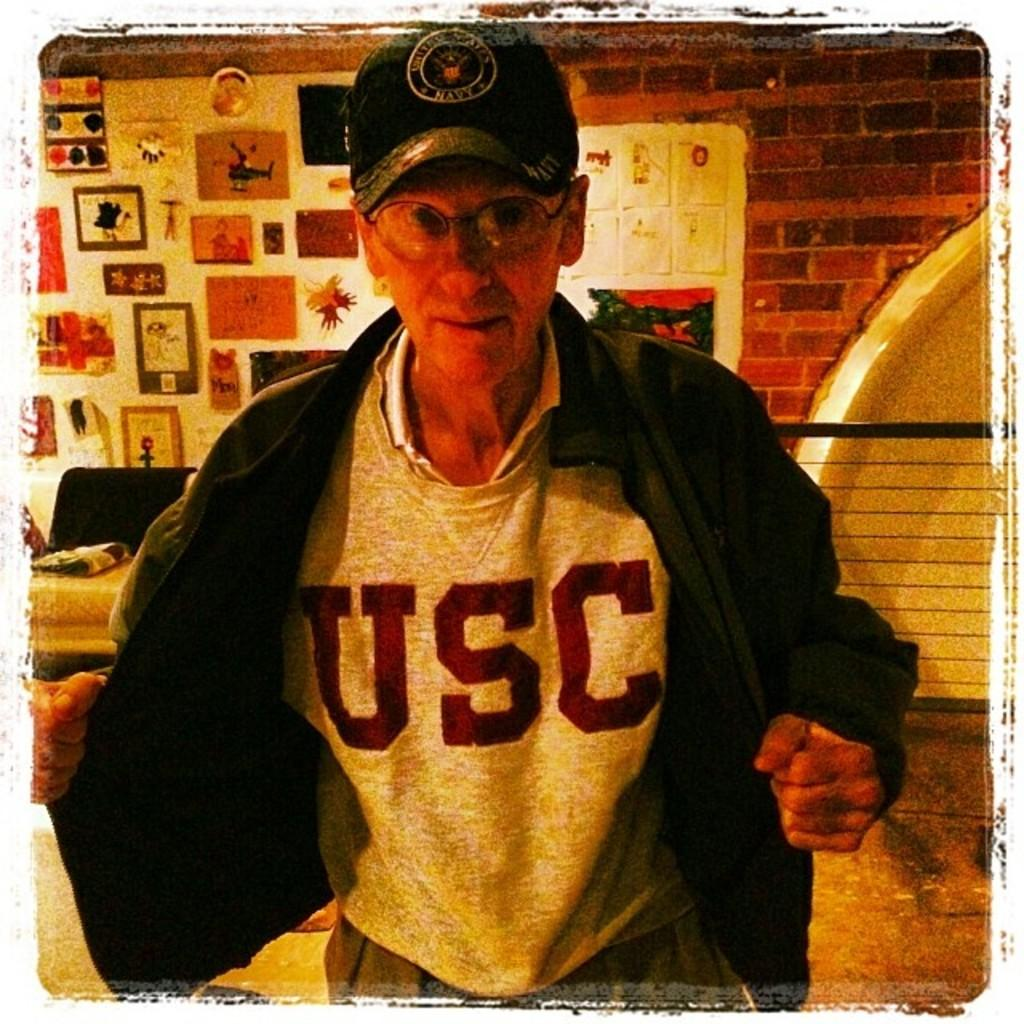<image>
Give a short and clear explanation of the subsequent image. An older man with his jacket opened and is wearing a sweatshirt underneath with the letters USC.s 